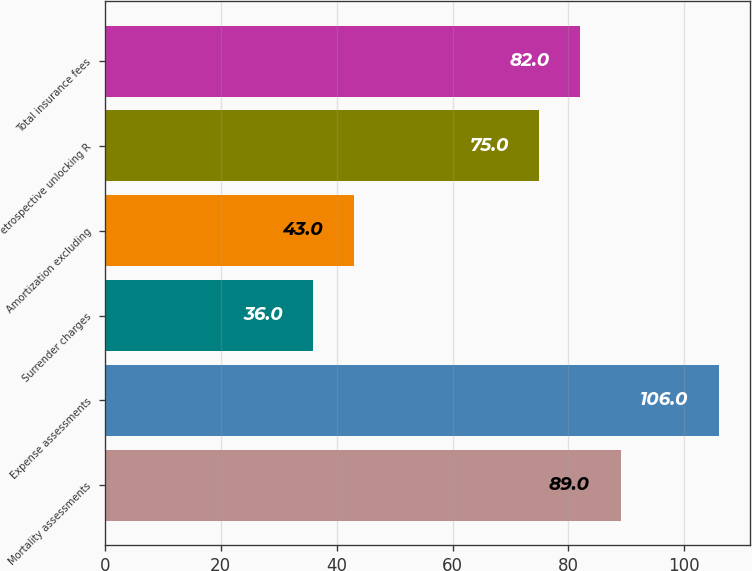Convert chart. <chart><loc_0><loc_0><loc_500><loc_500><bar_chart><fcel>Mortality assessments<fcel>Expense assessments<fcel>Surrender charges<fcel>Amortization excluding<fcel>etrospective unlocking R<fcel>Total insurance fees<nl><fcel>89<fcel>106<fcel>36<fcel>43<fcel>75<fcel>82<nl></chart> 